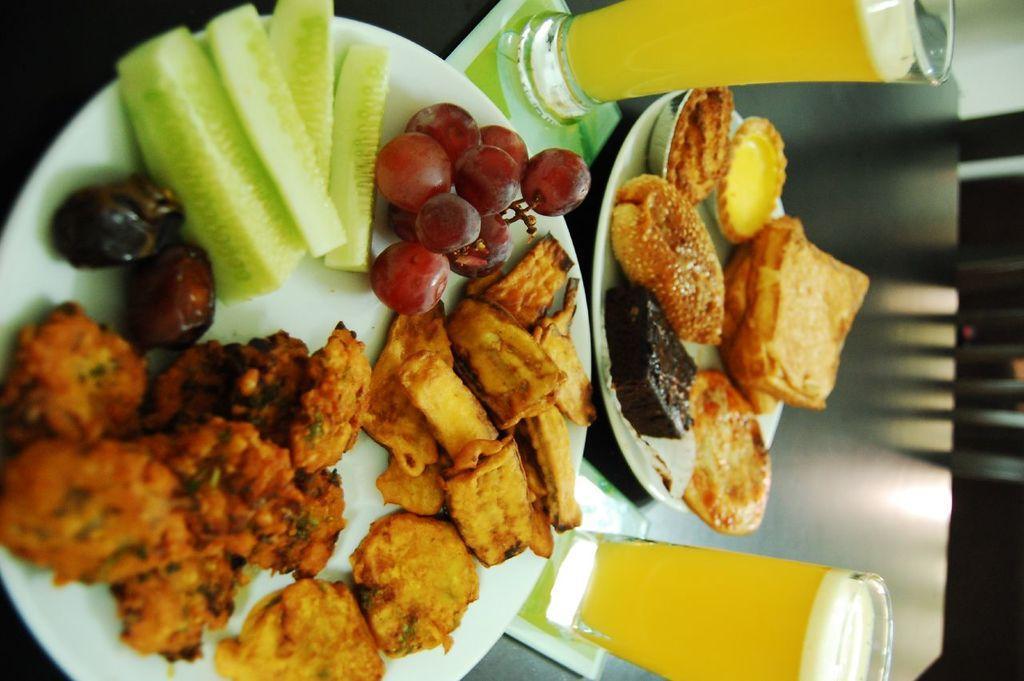Could you give a brief overview of what you see in this image? In this picture we can see a table and on the table there are plates and glasses. On the plates, there are some food items. On the right side of the image, it looks like a chair. 